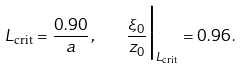<formula> <loc_0><loc_0><loc_500><loc_500>L _ { \text {crit} } = \frac { 0 . 9 0 } { a } \, , \quad \frac { \xi _ { 0 } } { z _ { 0 } } \Big | _ { L _ { \text {crit} } } = 0 . 9 6 \, .</formula> 